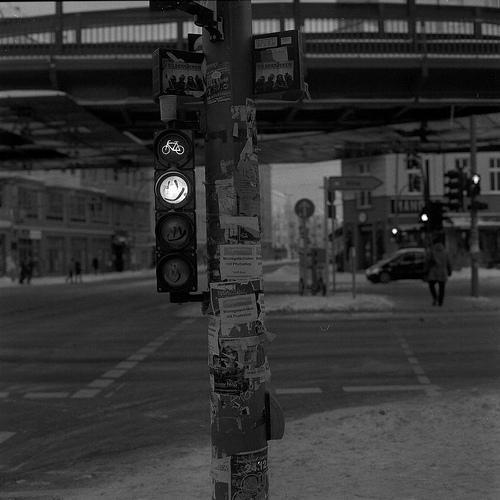How many circles are on the traffic light?
Give a very brief answer. 4. How many people are in this picture?
Give a very brief answer. 4. How many cars do you see?
Give a very brief answer. 1. 